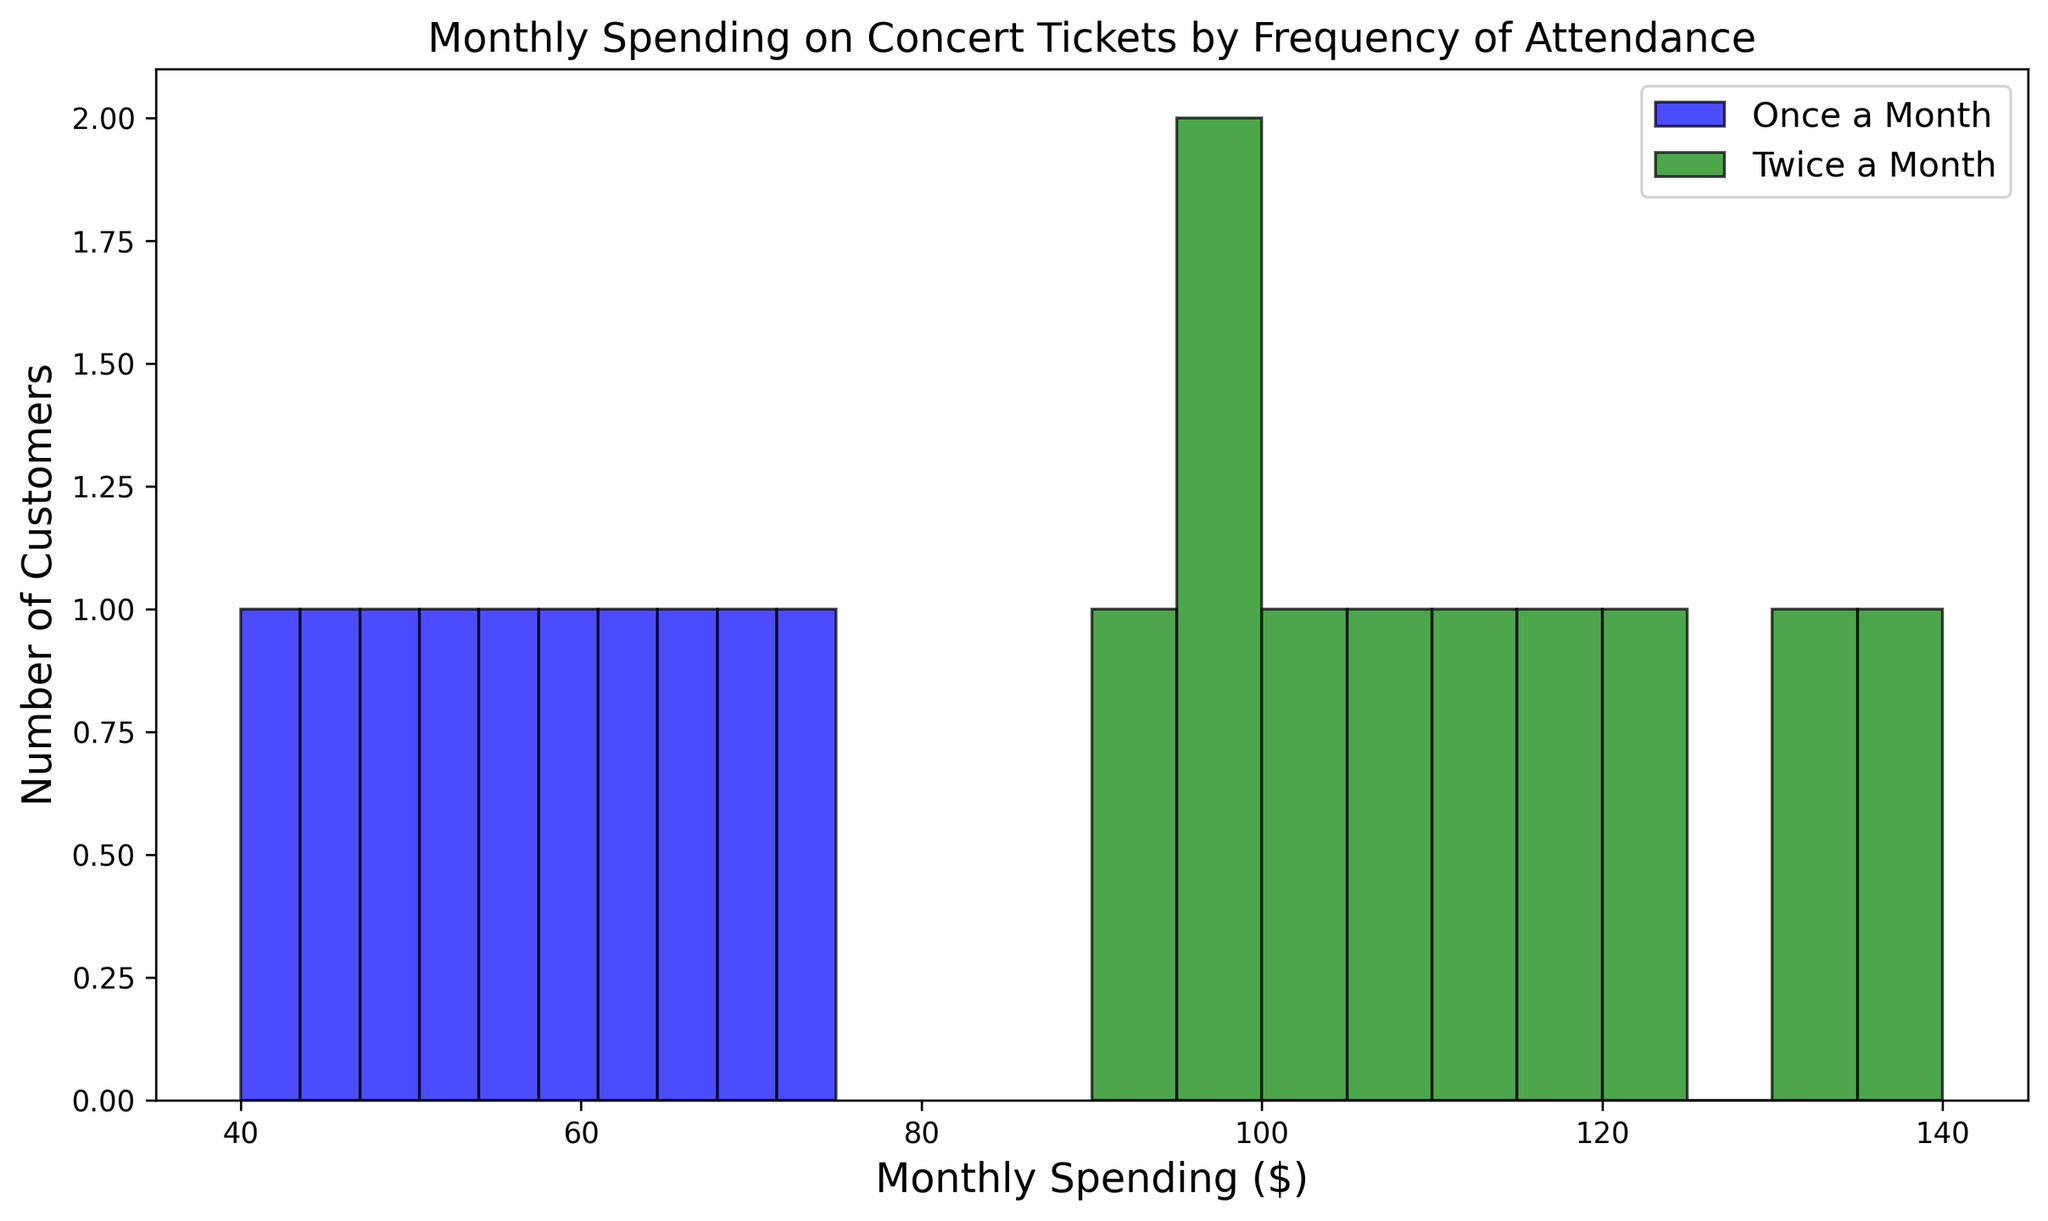What's the average monthly spending for customers who attend concerts once a month? To calculate the average monthly spending for customers who attend concerts once a month, sum all the spending values for this group and then divide by the number of observations. The sum is 50 + 45 + 55 + 60 + 70 + 65 + 40 + 75 + 52 + 63 = 575, and there are 10 observations. Therefore, the average is 575 / 10 = 57.5.
Answer: 57.5 What is the highest monthly spending value for customers who attend concerts twice a month? Locate the highest value in the data for customers who attend concerts twice a month. The values are 100, 120, 110, 95, 130, 90, 115, 105, 140, 98. The highest value is 140.
Answer: 140 Which group has a higher maximum monthly spending, once a month or twice a month? Compare the highest spending values from both groups. The highest value for 'Once a Month' is 75, and for 'Twice a Month' it is 140. The group 'Twice a Month' has the higher maximum monthly spending.
Answer: Twice a Month How many customers spend between $50 and $70 monthly if they attend concerts once a month? Count the number of bars in the histogram representing 'Once a Month' within the range $50 to $70. From the list of spending values 50, 45, 55, 60, 70, 65, 40, 75, 52, 63, there are 6 values (50, 55, 60, 70, 65, 52, 63) within the range.
Answer: 6 What is the median monthly spending for customers who attend concerts twice a month? To find the median, arrange the spending values for 'Twice a Month' in ascending order and find the middle value. The values are 90, 95, 98, 100, 105, 110, 115, 120, 130, 140. The median (middle value) for 10 data points is the average of the 5th and 6th values (105 and 110). Thus, the median is (105 + 110) / 2 = 107.5.
Answer: 107.5 Between $90 and $110, does 'Once a Month' or 'Twice a Month' have more customers? Count the number of customers in the 'Once a Month' and 'Twice a Month' groups whose spending is between $90 and $110. For 'Once a Month', no values fall in this range. For 'Twice a Month', the values 95, 98, 100, 105, 110 count in this range (5 customers). Therefore, 'Twice a Month' has more customers in this range.
Answer: Twice a Month What color represents the 'Once a Month' attenders in the histogram? Look at the legend of the histogram to determine the color associated with 'Once a Month'. It is specified that 'Once a Month' is colored blue.
Answer: Blue What is the total sum of monthly spending for customers attending twice a month? Sum all spending values for customers attending concerts twice a month. The values are 100, 120, 110, 95, 130, 90, 115, 105, 140, 98. The total sum is 100 + 120 + 110 + 95 + 130 + 90 + 115 + 105 + 140 + 98 = 1103.
Answer: 1103 